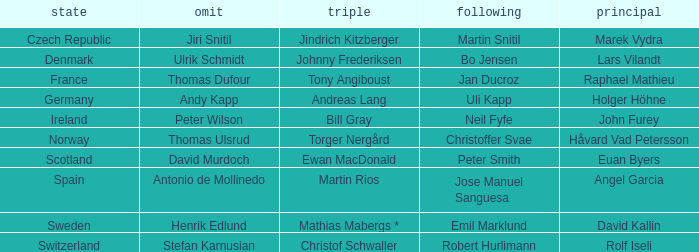Which Skip has a Third of tony angiboust? Thomas Dufour. 